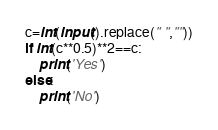Convert code to text. <code><loc_0><loc_0><loc_500><loc_500><_Python_>c=int(input().replace(" ",""))
if int(c**0.5)**2==c:
    print('Yes')
else:
    print('No')</code> 